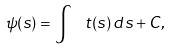Convert formula to latex. <formula><loc_0><loc_0><loc_500><loc_500>\psi ( s ) = \int \, \ t ( s ) \, d s + C ,</formula> 